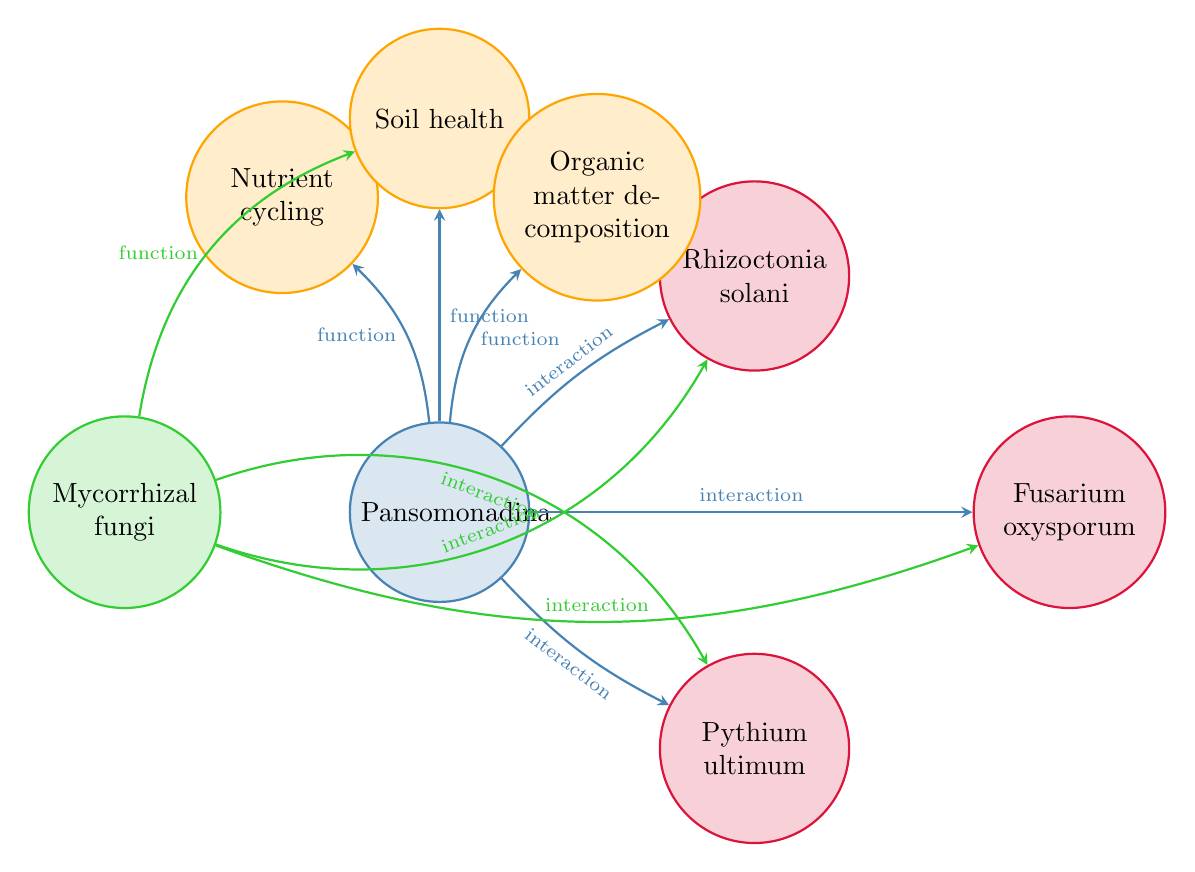What is the total number of nodes in the diagram? The nodes mentioned in the diagram include Pansomonadina, Rhizoctonia solani, Pythium ultimum, Fusarium oxysporum, Mycorrhizal fungi, Nutrient cycling, Soil health, and Organic matter decomposition. Counting them gives a total of eight nodes.
Answer: 8 Which pathogen is directly linked to Pansomonadina? The diagram shows three pathogens linked to Pansomonadina: Rhizoctonia solani, Pythium ultimum, and Fusarium oxysporum. Therefore, one example of a pathogen is Rhizoctonia solani.
Answer: Rhizoctonia solani What type of relationship exists between Pansomonadina and Organic matter decomposition? The diagram indicates that there is a functional relationship between Pansomonadina and Organic matter decomposition, as denoted by the arrow labeled "function" connecting the two nodes.
Answer: function How many interactions are indicated between Mycorrhizal fungi and soil-borne pathogens? The diagram reveals that Mycorrhizal fungi interact with three soil-borne pathogens: Rhizoctonia solani, Pythium ultimum, and Fusarium oxysporum. Thus, the total number of interactions is three.
Answer: 3 What role does Pansomonadina play in relation to soil health? The diagram demonstrates a functional relationship between Pansomonadina and Soil health, implying that Pansomonadina contributes positively to this aspect of soil ecosystem function.
Answer: function Which pathogen is not linked to Mycorrhizal fungi in the diagram? The diagram indicates that Mycorrhizal fungi do not have a direct connection to any pathogen other than Rhizoctonia solani, Pythium ultimum, and Fusarium oxysporum. Since these are the only pathogens listed, none are absent.
Answer: None Is there a relationship between Mycorrhizal fungi and Soil health? Yes, the diagram shows a functional relationship between Mycorrhizal fungi and Soil health, shown by an arrow labeled "function" directed towards the Soil health node.
Answer: function How does Pansomonadina contribute to Nutrient cycling? According to the diagram, Pansomonadina directly contributes to Nutrient cycling through a functional relationship, as indicated by an arrow labeled "function".
Answer: function What is the primary focus of the diagram? The primary focus of the diagram is to illustrate the relationships between Pansomonadina and soil-borne pathogens, as well as its ecological roles, including functions related to soil health and nutrient dynamics.
Answer: Relationships between Pansomonadina and soil-borne pathogens 